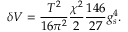<formula> <loc_0><loc_0><loc_500><loc_500>\delta V = { \frac { T ^ { 2 } } { 1 6 \pi ^ { 2 } } } { \frac { \chi ^ { 2 } } { 2 } } { \frac { 1 4 6 } { 2 7 } } g _ { s } ^ { 4 } .</formula> 